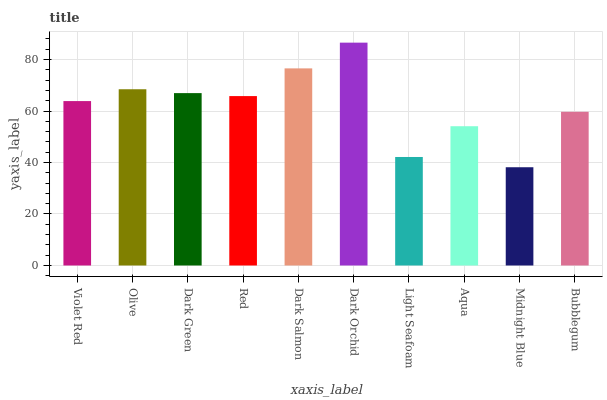Is Olive the minimum?
Answer yes or no. No. Is Olive the maximum?
Answer yes or no. No. Is Olive greater than Violet Red?
Answer yes or no. Yes. Is Violet Red less than Olive?
Answer yes or no. Yes. Is Violet Red greater than Olive?
Answer yes or no. No. Is Olive less than Violet Red?
Answer yes or no. No. Is Red the high median?
Answer yes or no. Yes. Is Violet Red the low median?
Answer yes or no. Yes. Is Light Seafoam the high median?
Answer yes or no. No. Is Olive the low median?
Answer yes or no. No. 